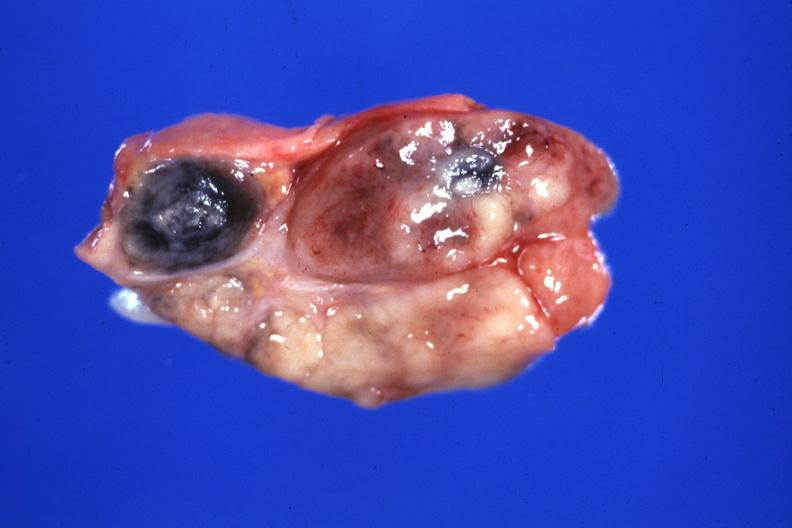s lymph node present?
Answer the question using a single word or phrase. Yes 